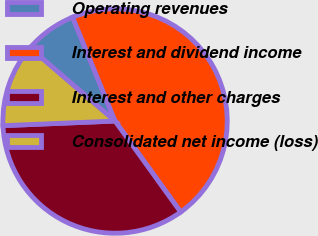<chart> <loc_0><loc_0><loc_500><loc_500><pie_chart><fcel>Operating revenues<fcel>Interest and dividend income<fcel>Interest and other charges<fcel>Consolidated net income (loss)<nl><fcel>7.51%<fcel>46.24%<fcel>34.28%<fcel>11.97%<nl></chart> 